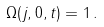Convert formula to latex. <formula><loc_0><loc_0><loc_500><loc_500>\Omega ( j , 0 , t ) = 1 \, .</formula> 